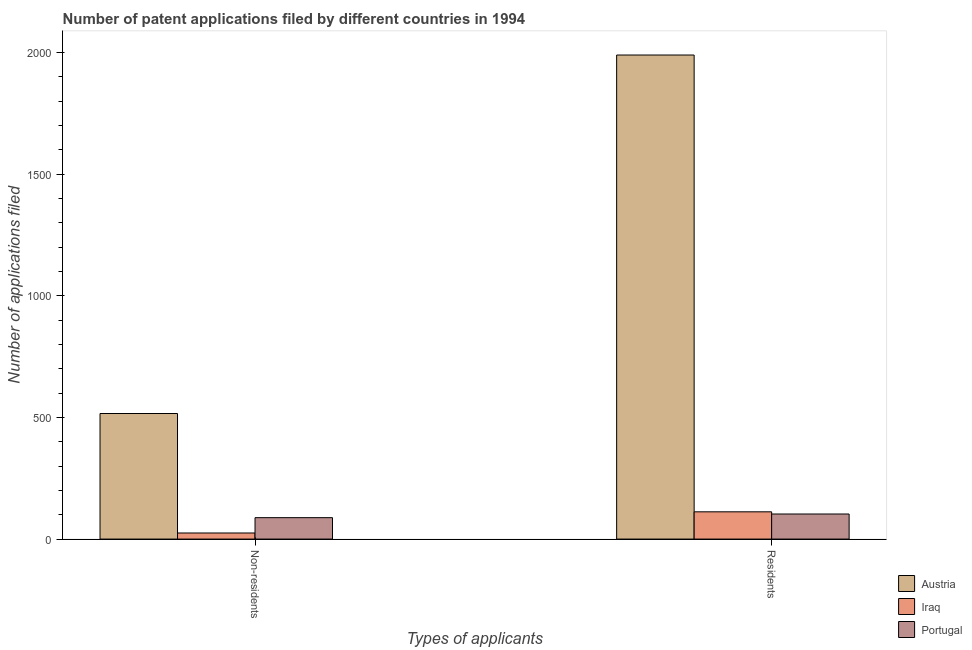How many groups of bars are there?
Your response must be concise. 2. How many bars are there on the 2nd tick from the right?
Provide a succinct answer. 3. What is the label of the 2nd group of bars from the left?
Your answer should be compact. Residents. What is the number of patent applications by residents in Portugal?
Keep it short and to the point. 103. Across all countries, what is the maximum number of patent applications by residents?
Keep it short and to the point. 1989. Across all countries, what is the minimum number of patent applications by residents?
Your answer should be very brief. 103. In which country was the number of patent applications by residents minimum?
Offer a terse response. Portugal. What is the total number of patent applications by residents in the graph?
Make the answer very short. 2204. What is the difference between the number of patent applications by residents in Iraq and that in Austria?
Keep it short and to the point. -1877. What is the difference between the number of patent applications by non residents in Austria and the number of patent applications by residents in Iraq?
Keep it short and to the point. 404. What is the average number of patent applications by residents per country?
Offer a terse response. 734.67. What is the difference between the number of patent applications by residents and number of patent applications by non residents in Austria?
Ensure brevity in your answer.  1473. In how many countries, is the number of patent applications by non residents greater than 400 ?
Your answer should be very brief. 1. What is the ratio of the number of patent applications by residents in Austria to that in Iraq?
Make the answer very short. 17.76. Is the number of patent applications by non residents in Portugal less than that in Iraq?
Your answer should be very brief. No. What does the 2nd bar from the left in Non-residents represents?
Your response must be concise. Iraq. What does the 2nd bar from the right in Non-residents represents?
Make the answer very short. Iraq. How many countries are there in the graph?
Your answer should be compact. 3. Are the values on the major ticks of Y-axis written in scientific E-notation?
Keep it short and to the point. No. Does the graph contain grids?
Provide a short and direct response. No. Where does the legend appear in the graph?
Ensure brevity in your answer.  Bottom right. How are the legend labels stacked?
Keep it short and to the point. Vertical. What is the title of the graph?
Your response must be concise. Number of patent applications filed by different countries in 1994. What is the label or title of the X-axis?
Your response must be concise. Types of applicants. What is the label or title of the Y-axis?
Your response must be concise. Number of applications filed. What is the Number of applications filed in Austria in Non-residents?
Offer a very short reply. 516. What is the Number of applications filed of Austria in Residents?
Provide a short and direct response. 1989. What is the Number of applications filed in Iraq in Residents?
Offer a very short reply. 112. What is the Number of applications filed in Portugal in Residents?
Make the answer very short. 103. Across all Types of applicants, what is the maximum Number of applications filed of Austria?
Provide a succinct answer. 1989. Across all Types of applicants, what is the maximum Number of applications filed of Iraq?
Provide a succinct answer. 112. Across all Types of applicants, what is the maximum Number of applications filed in Portugal?
Your response must be concise. 103. Across all Types of applicants, what is the minimum Number of applications filed in Austria?
Provide a short and direct response. 516. Across all Types of applicants, what is the minimum Number of applications filed in Iraq?
Offer a very short reply. 25. Across all Types of applicants, what is the minimum Number of applications filed of Portugal?
Ensure brevity in your answer.  88. What is the total Number of applications filed in Austria in the graph?
Keep it short and to the point. 2505. What is the total Number of applications filed of Iraq in the graph?
Your answer should be very brief. 137. What is the total Number of applications filed of Portugal in the graph?
Your answer should be compact. 191. What is the difference between the Number of applications filed of Austria in Non-residents and that in Residents?
Ensure brevity in your answer.  -1473. What is the difference between the Number of applications filed of Iraq in Non-residents and that in Residents?
Your response must be concise. -87. What is the difference between the Number of applications filed in Austria in Non-residents and the Number of applications filed in Iraq in Residents?
Your answer should be very brief. 404. What is the difference between the Number of applications filed in Austria in Non-residents and the Number of applications filed in Portugal in Residents?
Offer a very short reply. 413. What is the difference between the Number of applications filed in Iraq in Non-residents and the Number of applications filed in Portugal in Residents?
Offer a terse response. -78. What is the average Number of applications filed of Austria per Types of applicants?
Give a very brief answer. 1252.5. What is the average Number of applications filed in Iraq per Types of applicants?
Your answer should be compact. 68.5. What is the average Number of applications filed in Portugal per Types of applicants?
Offer a terse response. 95.5. What is the difference between the Number of applications filed of Austria and Number of applications filed of Iraq in Non-residents?
Provide a succinct answer. 491. What is the difference between the Number of applications filed of Austria and Number of applications filed of Portugal in Non-residents?
Make the answer very short. 428. What is the difference between the Number of applications filed of Iraq and Number of applications filed of Portugal in Non-residents?
Provide a succinct answer. -63. What is the difference between the Number of applications filed in Austria and Number of applications filed in Iraq in Residents?
Your answer should be very brief. 1877. What is the difference between the Number of applications filed of Austria and Number of applications filed of Portugal in Residents?
Offer a very short reply. 1886. What is the ratio of the Number of applications filed in Austria in Non-residents to that in Residents?
Your response must be concise. 0.26. What is the ratio of the Number of applications filed in Iraq in Non-residents to that in Residents?
Provide a succinct answer. 0.22. What is the ratio of the Number of applications filed in Portugal in Non-residents to that in Residents?
Your response must be concise. 0.85. What is the difference between the highest and the second highest Number of applications filed in Austria?
Your answer should be very brief. 1473. What is the difference between the highest and the second highest Number of applications filed in Iraq?
Ensure brevity in your answer.  87. What is the difference between the highest and the lowest Number of applications filed in Austria?
Your answer should be compact. 1473. What is the difference between the highest and the lowest Number of applications filed in Iraq?
Provide a succinct answer. 87. What is the difference between the highest and the lowest Number of applications filed in Portugal?
Ensure brevity in your answer.  15. 